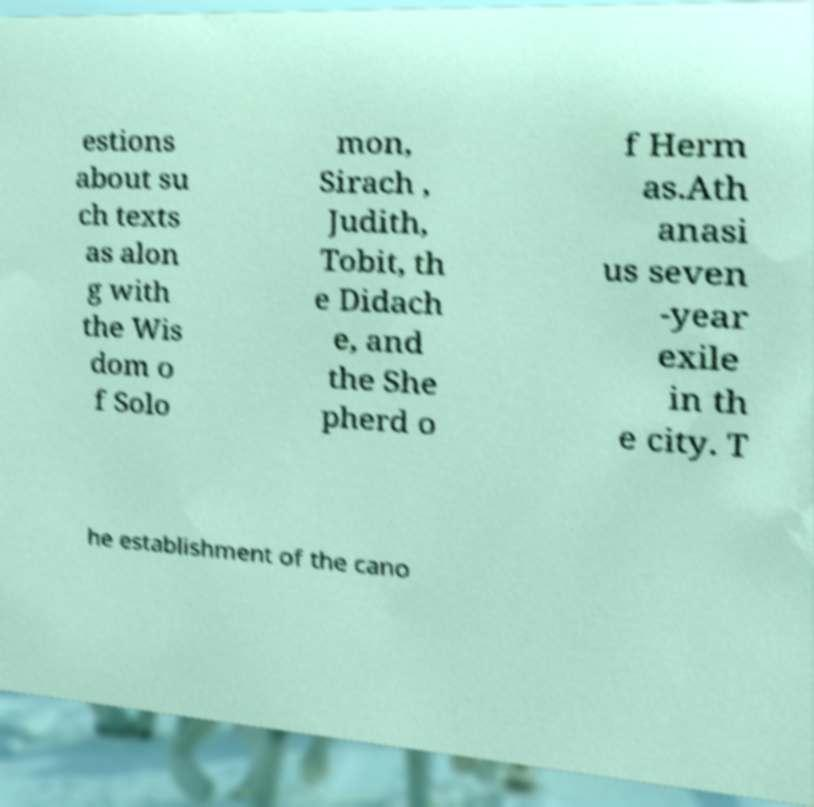Can you read and provide the text displayed in the image?This photo seems to have some interesting text. Can you extract and type it out for me? estions about su ch texts as alon g with the Wis dom o f Solo mon, Sirach , Judith, Tobit, th e Didach e, and the She pherd o f Herm as.Ath anasi us seven -year exile in th e city. T he establishment of the cano 